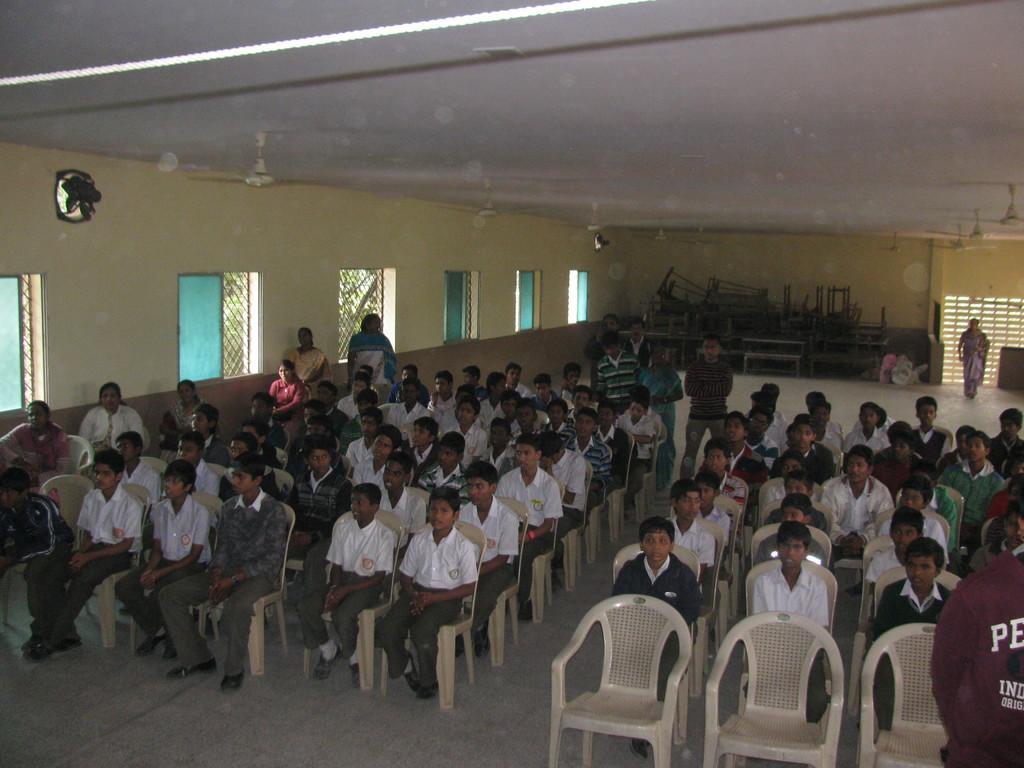Describe this image in one or two sentences. In this picture we can see some persons are sitting on the chairs. This is the floor. On the background we can see some benches. This is the wall. And these are the windows. 